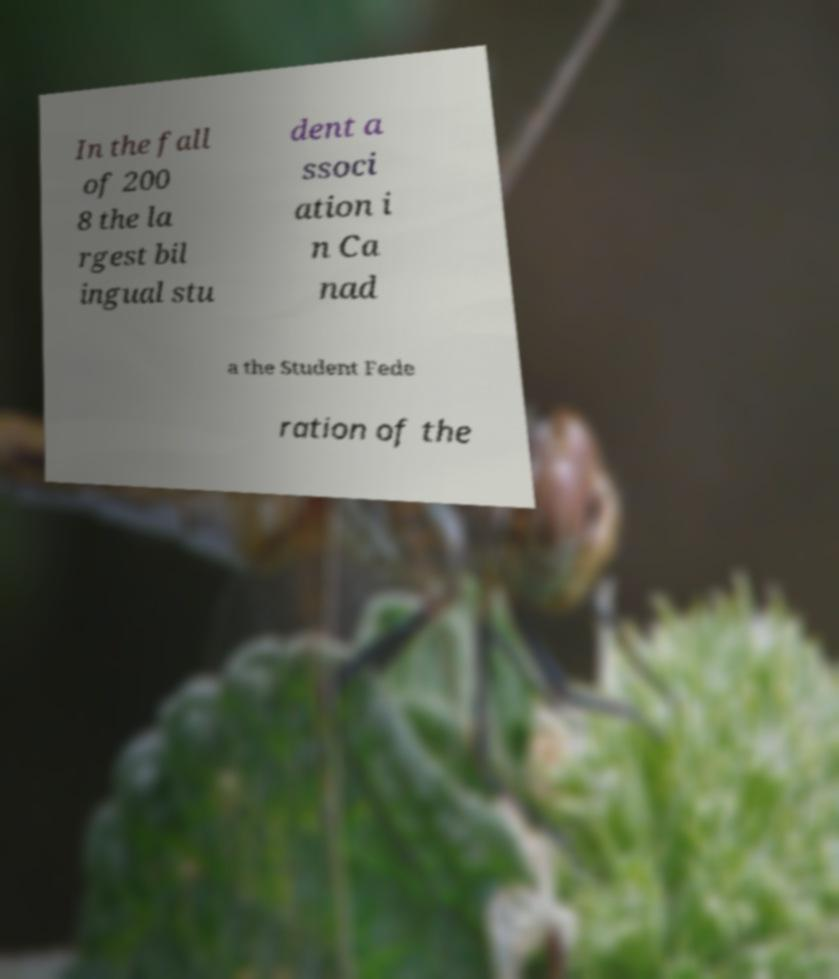Please read and relay the text visible in this image. What does it say? In the fall of 200 8 the la rgest bil ingual stu dent a ssoci ation i n Ca nad a the Student Fede ration of the 